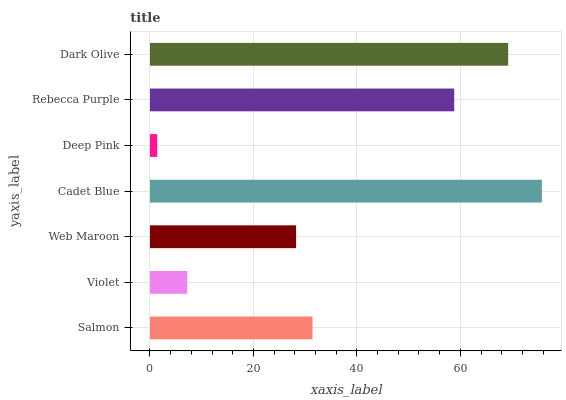Is Deep Pink the minimum?
Answer yes or no. Yes. Is Cadet Blue the maximum?
Answer yes or no. Yes. Is Violet the minimum?
Answer yes or no. No. Is Violet the maximum?
Answer yes or no. No. Is Salmon greater than Violet?
Answer yes or no. Yes. Is Violet less than Salmon?
Answer yes or no. Yes. Is Violet greater than Salmon?
Answer yes or no. No. Is Salmon less than Violet?
Answer yes or no. No. Is Salmon the high median?
Answer yes or no. Yes. Is Salmon the low median?
Answer yes or no. Yes. Is Deep Pink the high median?
Answer yes or no. No. Is Rebecca Purple the low median?
Answer yes or no. No. 